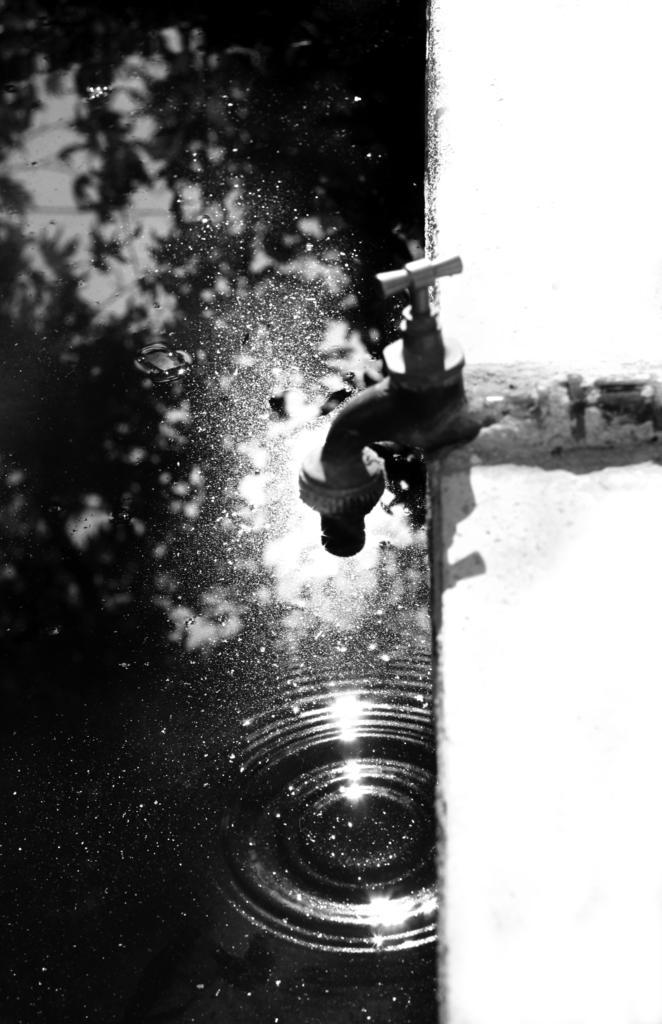Please provide a concise description of this image. This is a black and white picture, in this image we can see a tap and some water in the tub. 